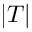<formula> <loc_0><loc_0><loc_500><loc_500>| T |</formula> 